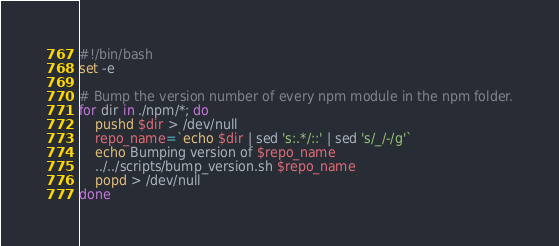Convert code to text. <code><loc_0><loc_0><loc_500><loc_500><_Bash_>#!/bin/bash
set -e

# Bump the version number of every npm module in the npm folder.
for dir in ./npm/*; do
    pushd $dir > /dev/null
    repo_name=`echo $dir | sed 's:.*/::' | sed 's/_/-/g'`
    echo Bumping version of $repo_name
    ../../scripts/bump_version.sh $repo_name
    popd > /dev/null
done
</code> 